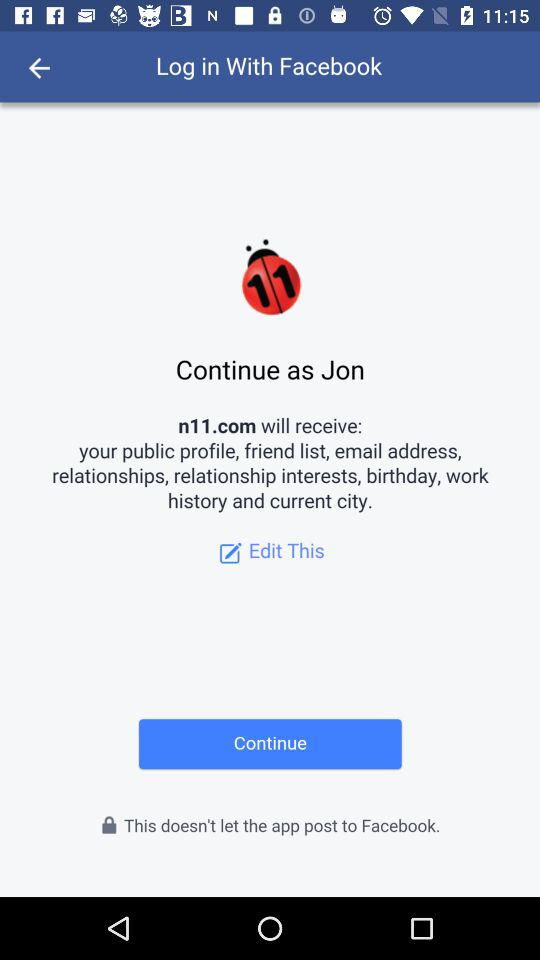How can we log in? You can log in with "Facebook". 